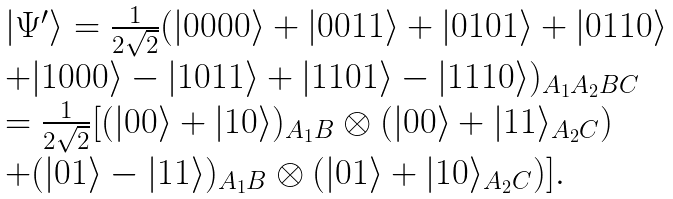Convert formula to latex. <formula><loc_0><loc_0><loc_500><loc_500>\begin{array} { l } | \Psi ^ { \prime } \rangle = \frac { 1 } { 2 \sqrt { 2 } } ( | 0 0 0 0 \rangle + | 0 0 1 1 \rangle + | 0 1 0 1 \rangle + | 0 1 1 0 \rangle \\ + | 1 0 0 0 \rangle - | 1 0 1 1 \rangle + | 1 1 0 1 \rangle - | 1 1 1 0 \rangle ) _ { A _ { 1 } A _ { 2 } B C } \\ = \frac { 1 } { 2 \sqrt { 2 } } [ ( | 0 0 \rangle + | 1 0 \rangle ) _ { A _ { 1 } B } \otimes ( | 0 0 \rangle + | 1 1 \rangle _ { A _ { 2 } C } ) \\ + ( | 0 1 \rangle - | 1 1 \rangle ) _ { A _ { 1 } B } \otimes ( | 0 1 \rangle + | 1 0 \rangle _ { A _ { 2 } C } ) ] . \\ \end{array}</formula> 